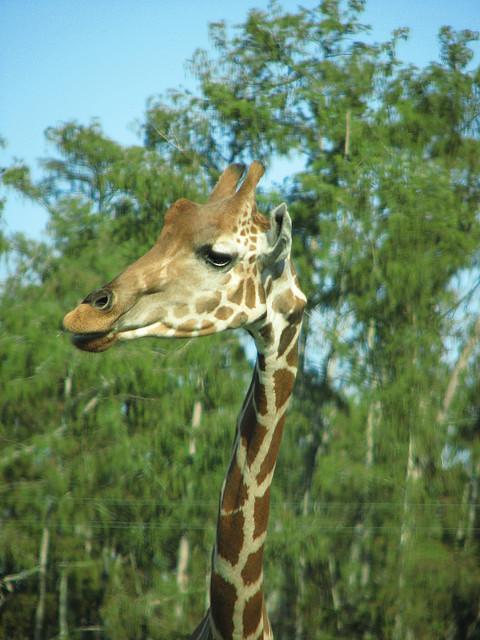How many giraffes are in the photo?
Give a very brief answer. 1. How many people are wearing brown shirt?
Give a very brief answer. 0. 